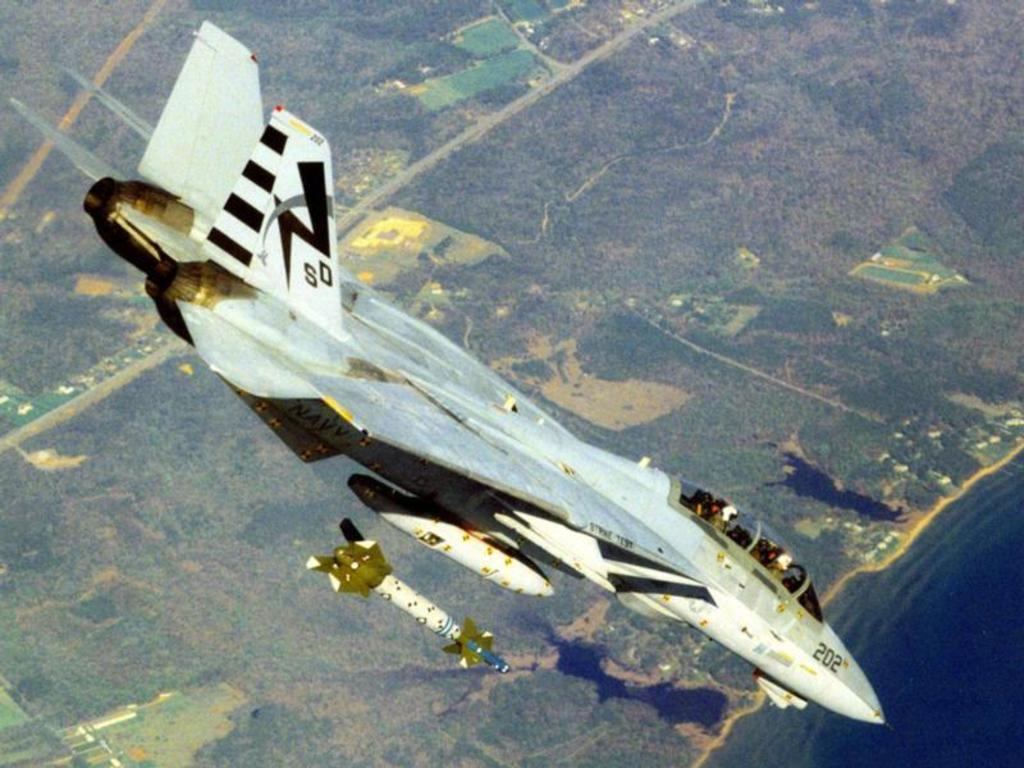<image>
Share a concise interpretation of the image provided. Fighter Jet in the sky with a label SD and numbers 202. 